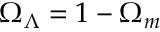<formula> <loc_0><loc_0><loc_500><loc_500>\Omega _ { \Lambda } = 1 - \Omega _ { m }</formula> 